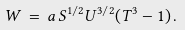Convert formula to latex. <formula><loc_0><loc_0><loc_500><loc_500>W \, = \, a \, S ^ { 1 / 2 } U ^ { 3 / 2 } ( T ^ { 3 } - 1 ) \, .</formula> 